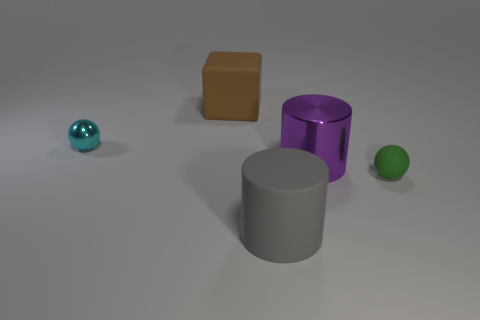There is a green ball; does it have the same size as the rubber thing behind the tiny green sphere? The green ball in the foreground appears to be smaller in size compared to the cylindrical object behind it, which looks like it's made of rubber. Without exact measurements, we can only speculate based on perspective, but the rubber object seems noticeably larger. 